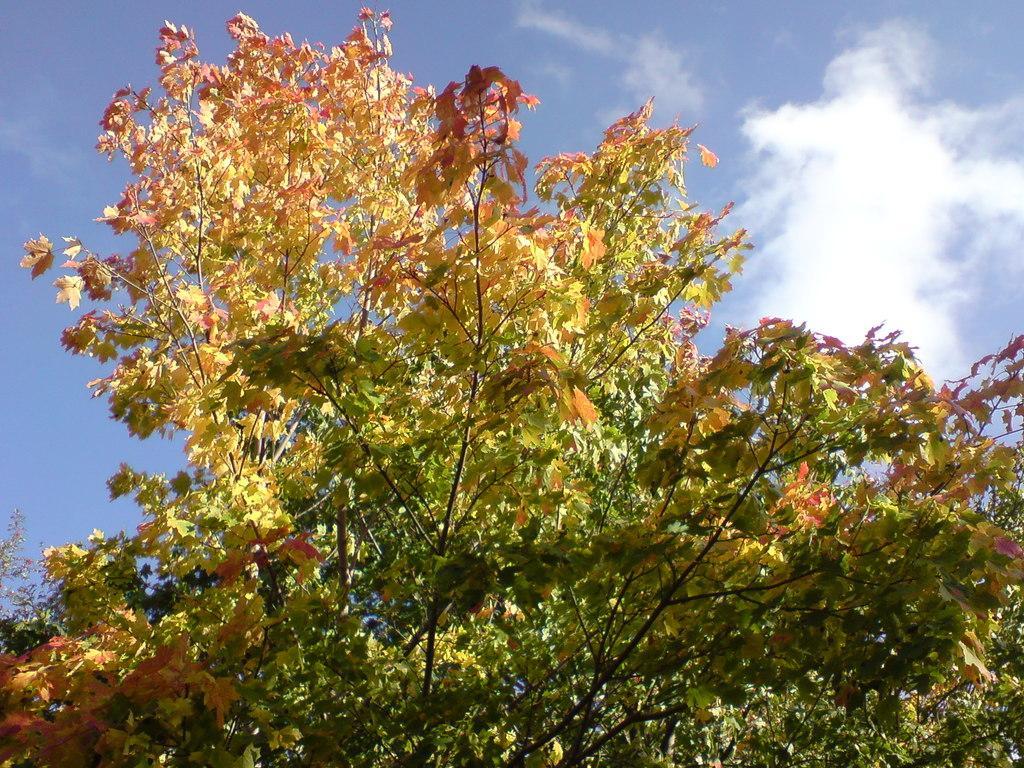Could you give a brief overview of what you see in this image? In the picture we can see a part of the tree with some green color leaves, some are yellow and some are red in color and behind it we can see a sky with clouds. 